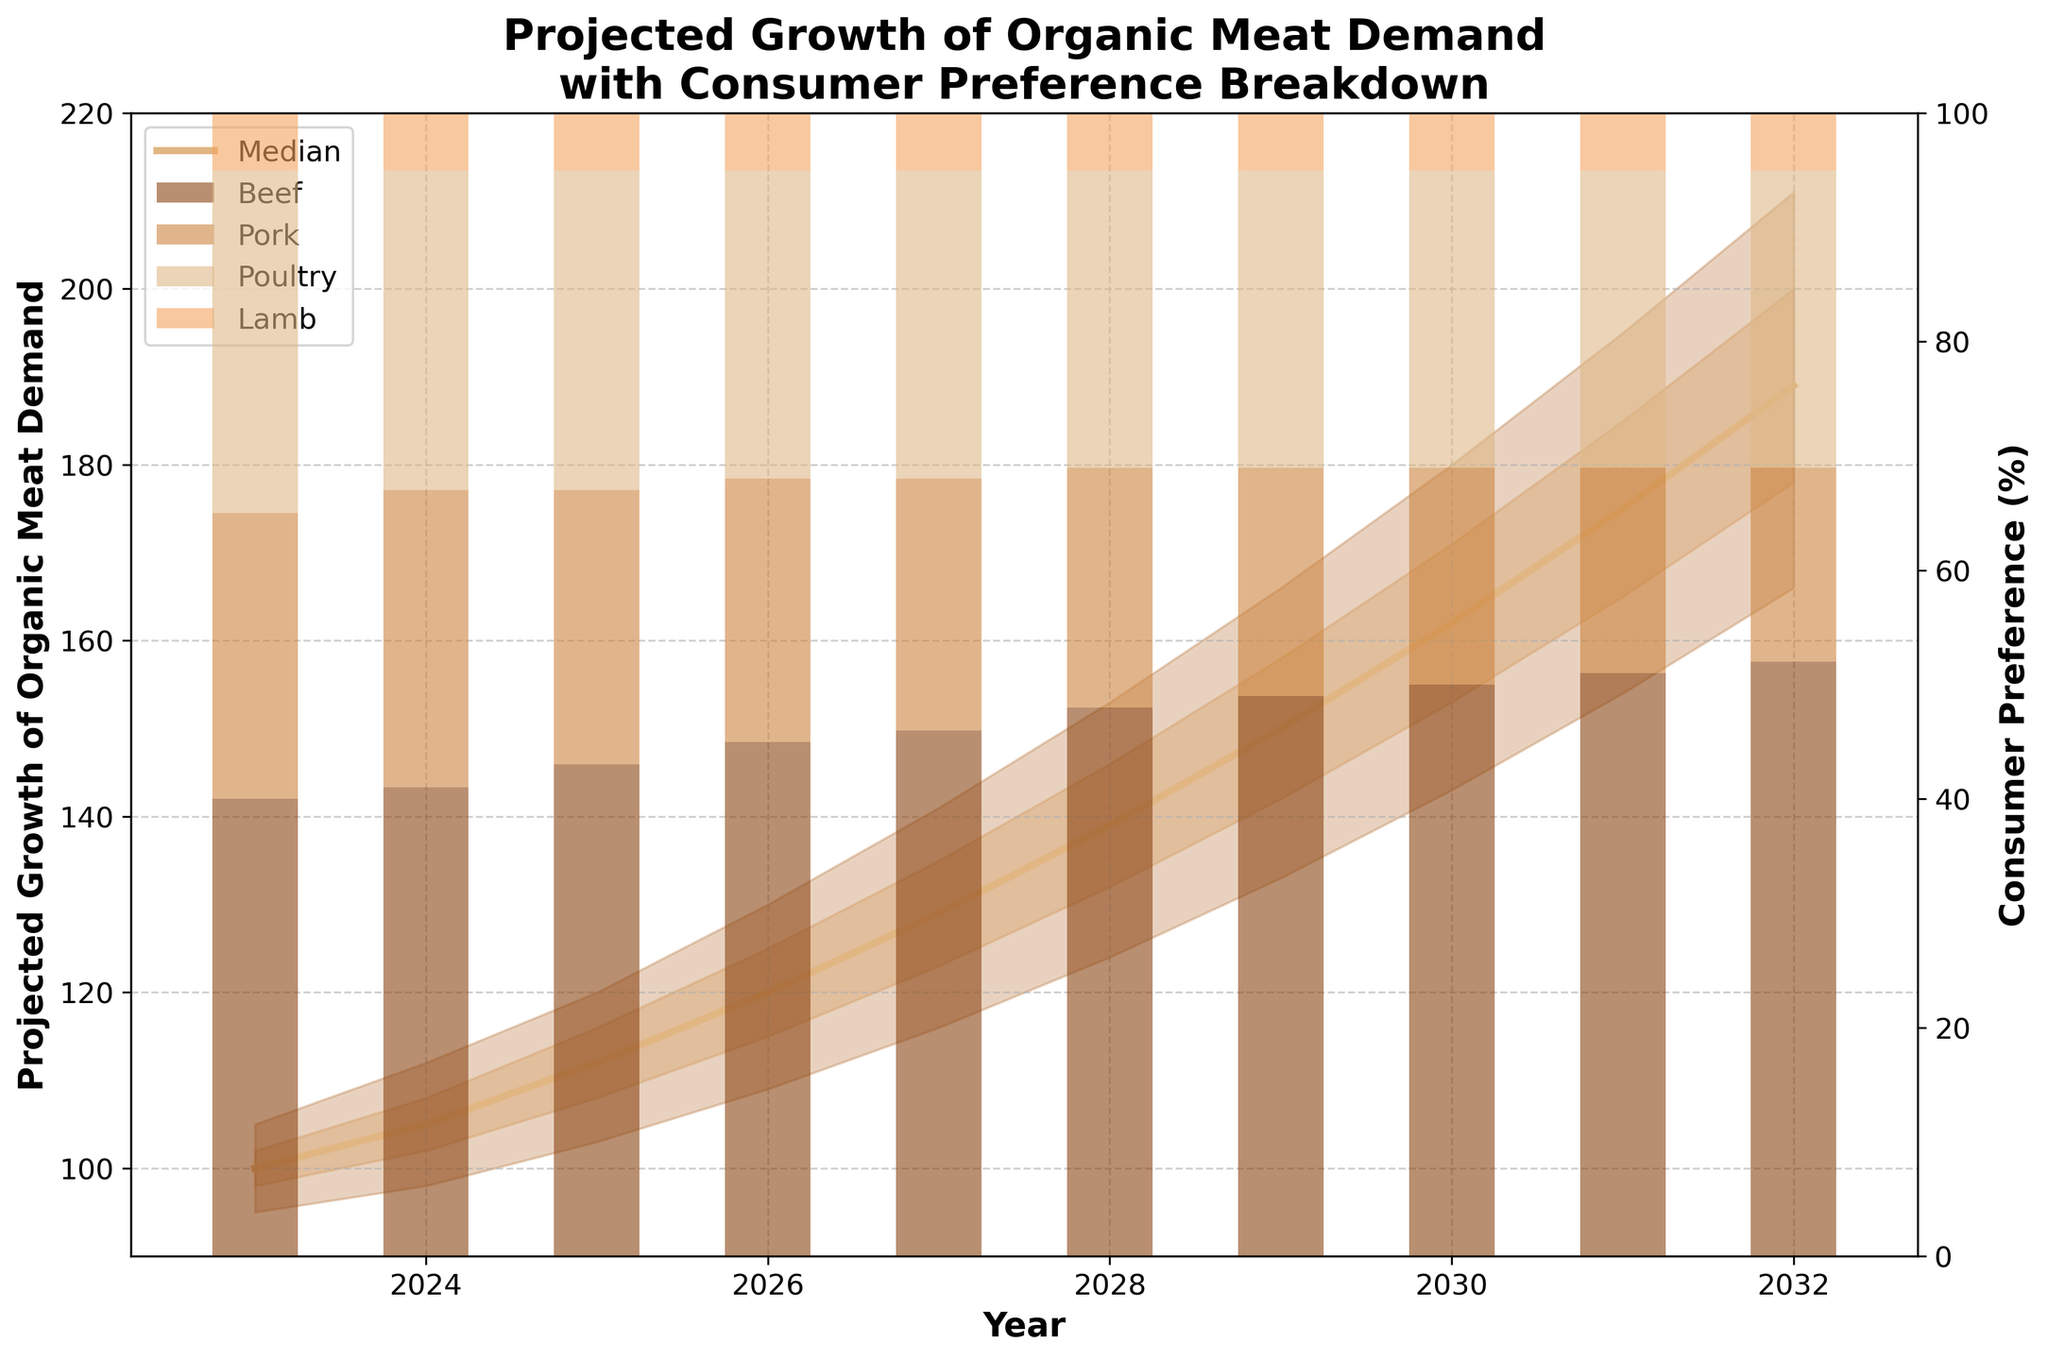What is the title of the figure? The title is usually located at the top of the figure and provides a brief description of the content. Here, the title reads, “Projected Growth of Organic Meat Demand with Consumer Preference Breakdown.”
Answer: Projected Growth of Organic Meat Demand with Consumer Preference Breakdown What is the projected median demand for organic meat in 2027? To find this, locate the median line (usually a solid line) on the fan chart for the year 2027. The projected median demand is 129 units.
Answer: 129 units Which meat type shows the highest consumer preference in 2023? The stacked bar chart on the right indicates consumer preferences for meat types. In 2023, Beef has the highest preference at 40%.
Answer: Beef What is the projected range of organic meat demand in 2030 according to the 10th and 90th percentiles? Look at the shaded regions indicating the 10th and 90th percentiles for the year 2030. The range is from 143 to 180 units.
Answer: 143 to 180 units What is the average projected median demand from 2023 to 2025? To find the average, sum the median values for years 2023, 2024, and 2025, then divide by 3. (100 + 105 + 112)/3 = 317/3 = 105.67.
Answer: 105.67 units How does consumer preference for poultry change from 2023 to 2032? Check the heights of the poultry segment in the stacked bar for 2023 and 2032. In 2023 it is 30%, and in 2032 it is 26%. The preference decreases by 4%.
Answer: Decreases by 4% In which year is the projected median demand expected to surpass 150 units? Identify the year at which the median line crosses the 150 units mark; it surpasses 150 units in 2029.
Answer: 2029 How much higher is the projected upper 75th percentile value than the projected median in 2028? The upper 75th percentile value for 2028 is 146 units, and the median is 139 units. The difference is 146 - 139 = 7 units.
Answer: 7 units Which year shows the highest projected median demand and what is its value? Locate the point on the median line with the highest value. The year 2032 has the highest median at 189 units.
Answer: 2032, 189 units Is the distribution of organic meat demand becoming more uncertain over time? Evaluate the spread between the 10th and 90th percentiles over the years. The spread increases from 10 units in 2023 to 45 units in 2032, indicating increasing uncertainty.
Answer: Yes, more uncertain 